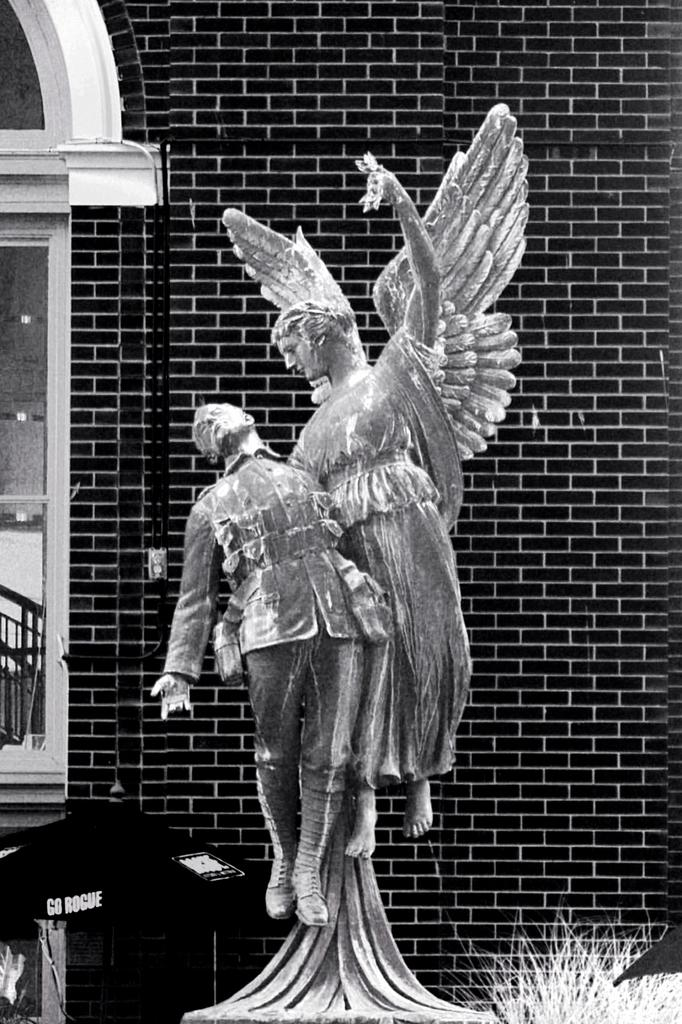What is the main subject in the center of the image? There is a statue in the center of the image. What can be seen in the background of the image? There is a wall and a window in the background of the image. What type of vegetation is at the bottom of the image? There is grass at the bottom of the image. What structure is located on the left side of the image? There is a tent on the left side of the image. What type of mask is hanging from the statue in the image? There is no mask present in the image; it only features a statue, a wall, a window, grass, and a tent. 